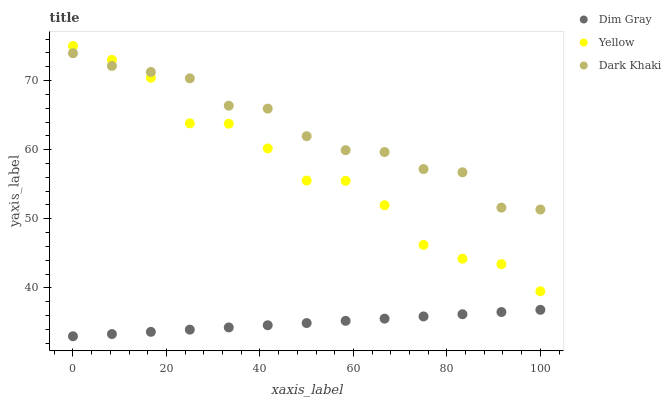Does Dim Gray have the minimum area under the curve?
Answer yes or no. Yes. Does Dark Khaki have the maximum area under the curve?
Answer yes or no. Yes. Does Yellow have the minimum area under the curve?
Answer yes or no. No. Does Yellow have the maximum area under the curve?
Answer yes or no. No. Is Dim Gray the smoothest?
Answer yes or no. Yes. Is Yellow the roughest?
Answer yes or no. Yes. Is Yellow the smoothest?
Answer yes or no. No. Is Dim Gray the roughest?
Answer yes or no. No. Does Dim Gray have the lowest value?
Answer yes or no. Yes. Does Yellow have the lowest value?
Answer yes or no. No. Does Yellow have the highest value?
Answer yes or no. Yes. Does Dim Gray have the highest value?
Answer yes or no. No. Is Dim Gray less than Dark Khaki?
Answer yes or no. Yes. Is Yellow greater than Dim Gray?
Answer yes or no. Yes. Does Yellow intersect Dark Khaki?
Answer yes or no. Yes. Is Yellow less than Dark Khaki?
Answer yes or no. No. Is Yellow greater than Dark Khaki?
Answer yes or no. No. Does Dim Gray intersect Dark Khaki?
Answer yes or no. No. 